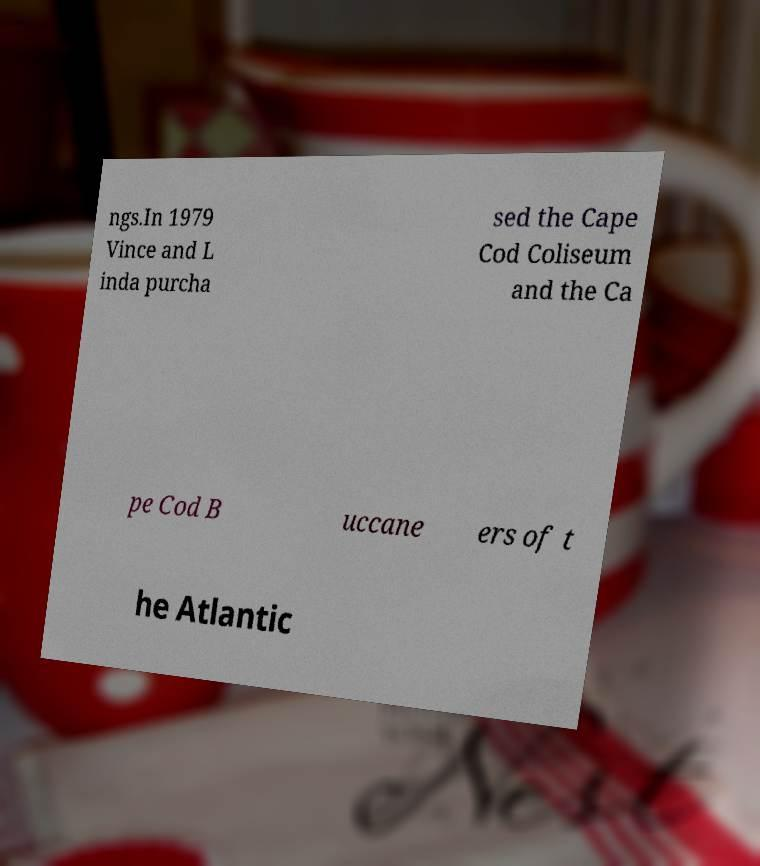For documentation purposes, I need the text within this image transcribed. Could you provide that? ngs.In 1979 Vince and L inda purcha sed the Cape Cod Coliseum and the Ca pe Cod B uccane ers of t he Atlantic 